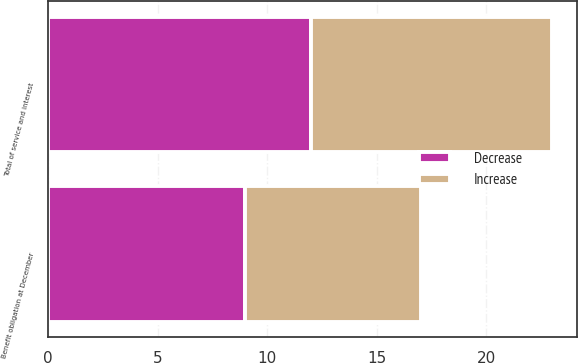Convert chart to OTSL. <chart><loc_0><loc_0><loc_500><loc_500><stacked_bar_chart><ecel><fcel>Total of service and interest<fcel>Benefit obligation at December<nl><fcel>Decrease<fcel>12<fcel>9<nl><fcel>Increase<fcel>11<fcel>8<nl></chart> 